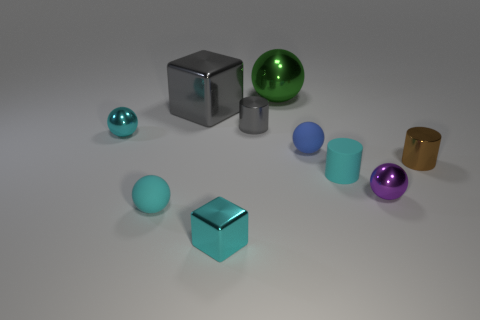Subtract all blue spheres. How many spheres are left? 4 Subtract all green metallic balls. How many balls are left? 4 Subtract all blue balls. Subtract all red cylinders. How many balls are left? 4 Subtract all cubes. How many objects are left? 8 Add 6 small cyan matte cylinders. How many small cyan matte cylinders exist? 7 Subtract 0 blue cubes. How many objects are left? 10 Subtract all gray metal things. Subtract all small cyan matte spheres. How many objects are left? 7 Add 3 gray objects. How many gray objects are left? 5 